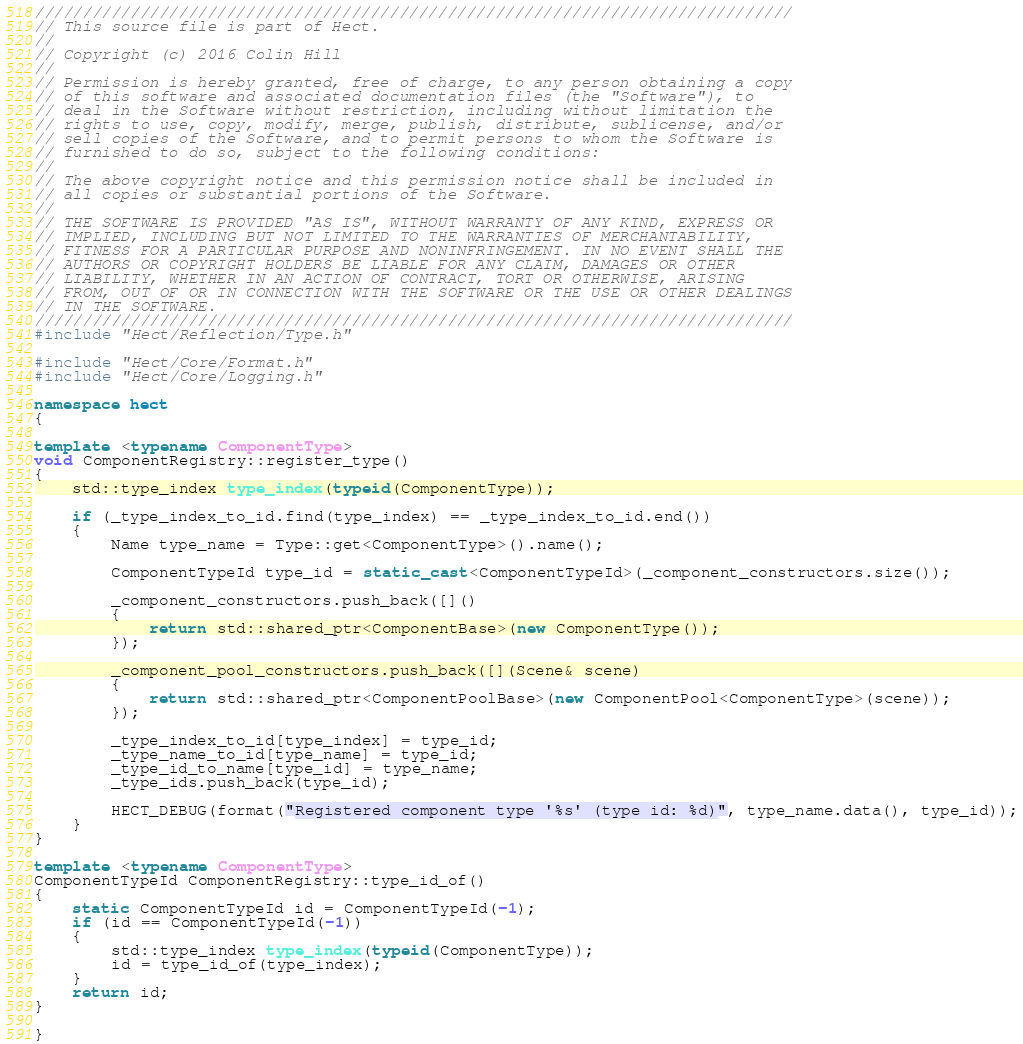Convert code to text. <code><loc_0><loc_0><loc_500><loc_500><_C++_>///////////////////////////////////////////////////////////////////////////////
// This source file is part of Hect.
//
// Copyright (c) 2016 Colin Hill
//
// Permission is hereby granted, free of charge, to any person obtaining a copy
// of this software and associated documentation files (the "Software"), to
// deal in the Software without restriction, including without limitation the
// rights to use, copy, modify, merge, publish, distribute, sublicense, and/or
// sell copies of the Software, and to permit persons to whom the Software is
// furnished to do so, subject to the following conditions:
//
// The above copyright notice and this permission notice shall be included in
// all copies or substantial portions of the Software.
//
// THE SOFTWARE IS PROVIDED "AS IS", WITHOUT WARRANTY OF ANY KIND, EXPRESS OR
// IMPLIED, INCLUDING BUT NOT LIMITED TO THE WARRANTIES OF MERCHANTABILITY,
// FITNESS FOR A PARTICULAR PURPOSE AND NONINFRINGEMENT. IN NO EVENT SHALL THE
// AUTHORS OR COPYRIGHT HOLDERS BE LIABLE FOR ANY CLAIM, DAMAGES OR OTHER
// LIABILITY, WHETHER IN AN ACTION OF CONTRACT, TORT OR OTHERWISE, ARISING
// FROM, OUT OF OR IN CONNECTION WITH THE SOFTWARE OR THE USE OR OTHER DEALINGS
// IN THE SOFTWARE.
///////////////////////////////////////////////////////////////////////////////
#include "Hect/Reflection/Type.h"

#include "Hect/Core/Format.h"
#include "Hect/Core/Logging.h"

namespace hect
{

template <typename ComponentType>
void ComponentRegistry::register_type()
{
    std::type_index type_index(typeid(ComponentType));

    if (_type_index_to_id.find(type_index) == _type_index_to_id.end())
    {
        Name type_name = Type::get<ComponentType>().name();

        ComponentTypeId type_id = static_cast<ComponentTypeId>(_component_constructors.size());

        _component_constructors.push_back([]()
        {
            return std::shared_ptr<ComponentBase>(new ComponentType());
        });

        _component_pool_constructors.push_back([](Scene& scene)
        {
            return std::shared_ptr<ComponentPoolBase>(new ComponentPool<ComponentType>(scene));
        });

        _type_index_to_id[type_index] = type_id;
        _type_name_to_id[type_name] = type_id;
        _type_id_to_name[type_id] = type_name;
        _type_ids.push_back(type_id);

        HECT_DEBUG(format("Registered component type '%s' (type id: %d)", type_name.data(), type_id));
    }
}

template <typename ComponentType>
ComponentTypeId ComponentRegistry::type_id_of()
{
    static ComponentTypeId id = ComponentTypeId(-1);
    if (id == ComponentTypeId(-1))
    {
        std::type_index type_index(typeid(ComponentType));
        id = type_id_of(type_index);
    }
    return id;
}

}
</code> 